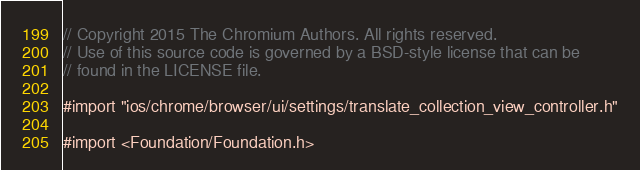<code> <loc_0><loc_0><loc_500><loc_500><_ObjectiveC_>// Copyright 2015 The Chromium Authors. All rights reserved.
// Use of this source code is governed by a BSD-style license that can be
// found in the LICENSE file.

#import "ios/chrome/browser/ui/settings/translate_collection_view_controller.h"

#import <Foundation/Foundation.h></code> 